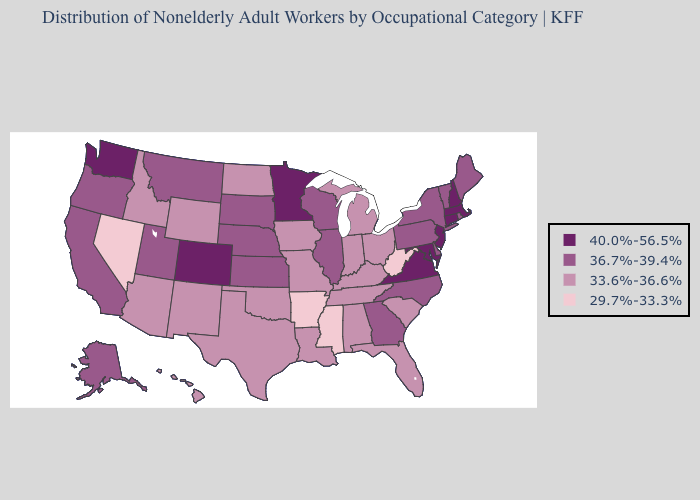Does Montana have the lowest value in the USA?
Write a very short answer. No. What is the value of Hawaii?
Keep it brief. 33.6%-36.6%. Name the states that have a value in the range 33.6%-36.6%?
Give a very brief answer. Alabama, Arizona, Florida, Hawaii, Idaho, Indiana, Iowa, Kentucky, Louisiana, Michigan, Missouri, New Mexico, North Dakota, Ohio, Oklahoma, South Carolina, Tennessee, Texas, Wyoming. Name the states that have a value in the range 36.7%-39.4%?
Concise answer only. Alaska, California, Delaware, Georgia, Illinois, Kansas, Maine, Montana, Nebraska, New York, North Carolina, Oregon, Pennsylvania, Rhode Island, South Dakota, Utah, Vermont, Wisconsin. Does the first symbol in the legend represent the smallest category?
Short answer required. No. What is the value of Mississippi?
Quick response, please. 29.7%-33.3%. Among the states that border Alabama , does Florida have the highest value?
Answer briefly. No. Does the map have missing data?
Be succinct. No. What is the value of Maine?
Be succinct. 36.7%-39.4%. What is the value of Texas?
Short answer required. 33.6%-36.6%. Which states hav the highest value in the Northeast?
Quick response, please. Connecticut, Massachusetts, New Hampshire, New Jersey. What is the value of Texas?
Be succinct. 33.6%-36.6%. What is the value of Kansas?
Be succinct. 36.7%-39.4%. Does California have the highest value in the West?
Concise answer only. No. Does Iowa have the same value as Tennessee?
Answer briefly. Yes. 